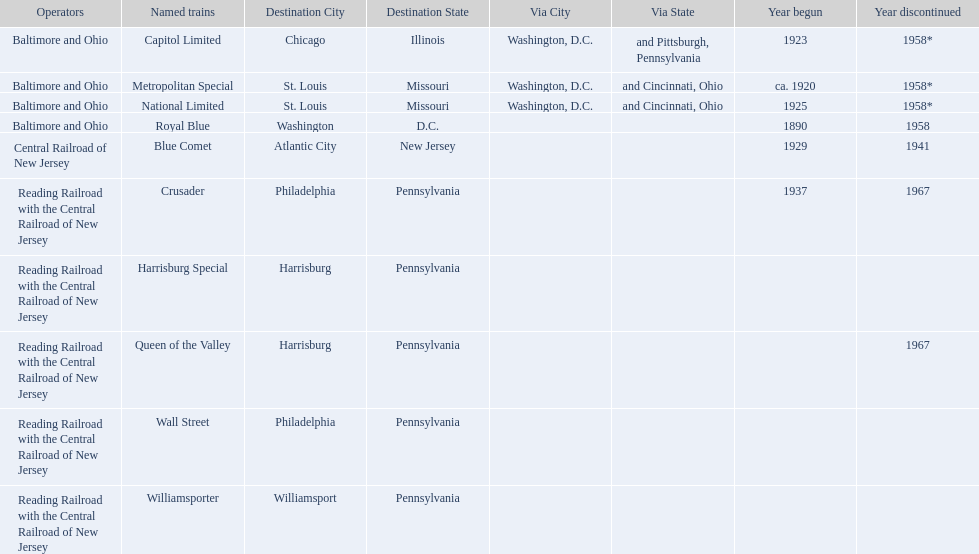Which of the trains are operated by reading railroad with the central railroad of new jersey? Crusader, Harrisburg Special, Queen of the Valley, Wall Street, Williamsporter. Of these trains, which of them had a destination of philadelphia, pennsylvania? Crusader, Wall Street. Out of these two trains, which one is discontinued? Crusader. What were all of the destinations? Chicago, Illinois via Washington, D.C. and Pittsburgh, Pennsylvania, St. Louis, Missouri via Washington, D.C. and Cincinnati, Ohio, St. Louis, Missouri via Washington, D.C. and Cincinnati, Ohio, Washington, D.C., Atlantic City, New Jersey, Philadelphia, Pennsylvania, Harrisburg, Pennsylvania, Harrisburg, Pennsylvania, Philadelphia, Pennsylvania, Williamsport, Pennsylvania. And what were the names of the trains? Capitol Limited, Metropolitan Special, National Limited, Royal Blue, Blue Comet, Crusader, Harrisburg Special, Queen of the Valley, Wall Street, Williamsporter. Of those, and along with wall street, which train ran to philadelphia, pennsylvania? Crusader. 